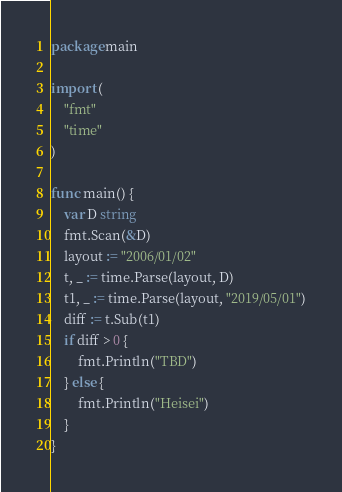Convert code to text. <code><loc_0><loc_0><loc_500><loc_500><_Go_>package main

import (
	"fmt"
	"time"
)

func main() {
	var D string
	fmt.Scan(&D)
	layout := "2006/01/02"
	t, _ := time.Parse(layout, D)
	t1, _ := time.Parse(layout, "2019/05/01")
	diff := t.Sub(t1)
	if diff > 0 {
		fmt.Println("TBD")
	} else {
		fmt.Println("Heisei")
	}
}
</code> 